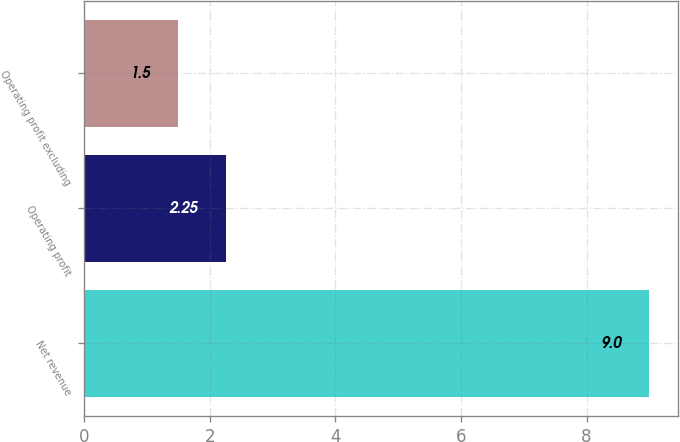Convert chart to OTSL. <chart><loc_0><loc_0><loc_500><loc_500><bar_chart><fcel>Net revenue<fcel>Operating profit<fcel>Operating profit excluding<nl><fcel>9<fcel>2.25<fcel>1.5<nl></chart> 